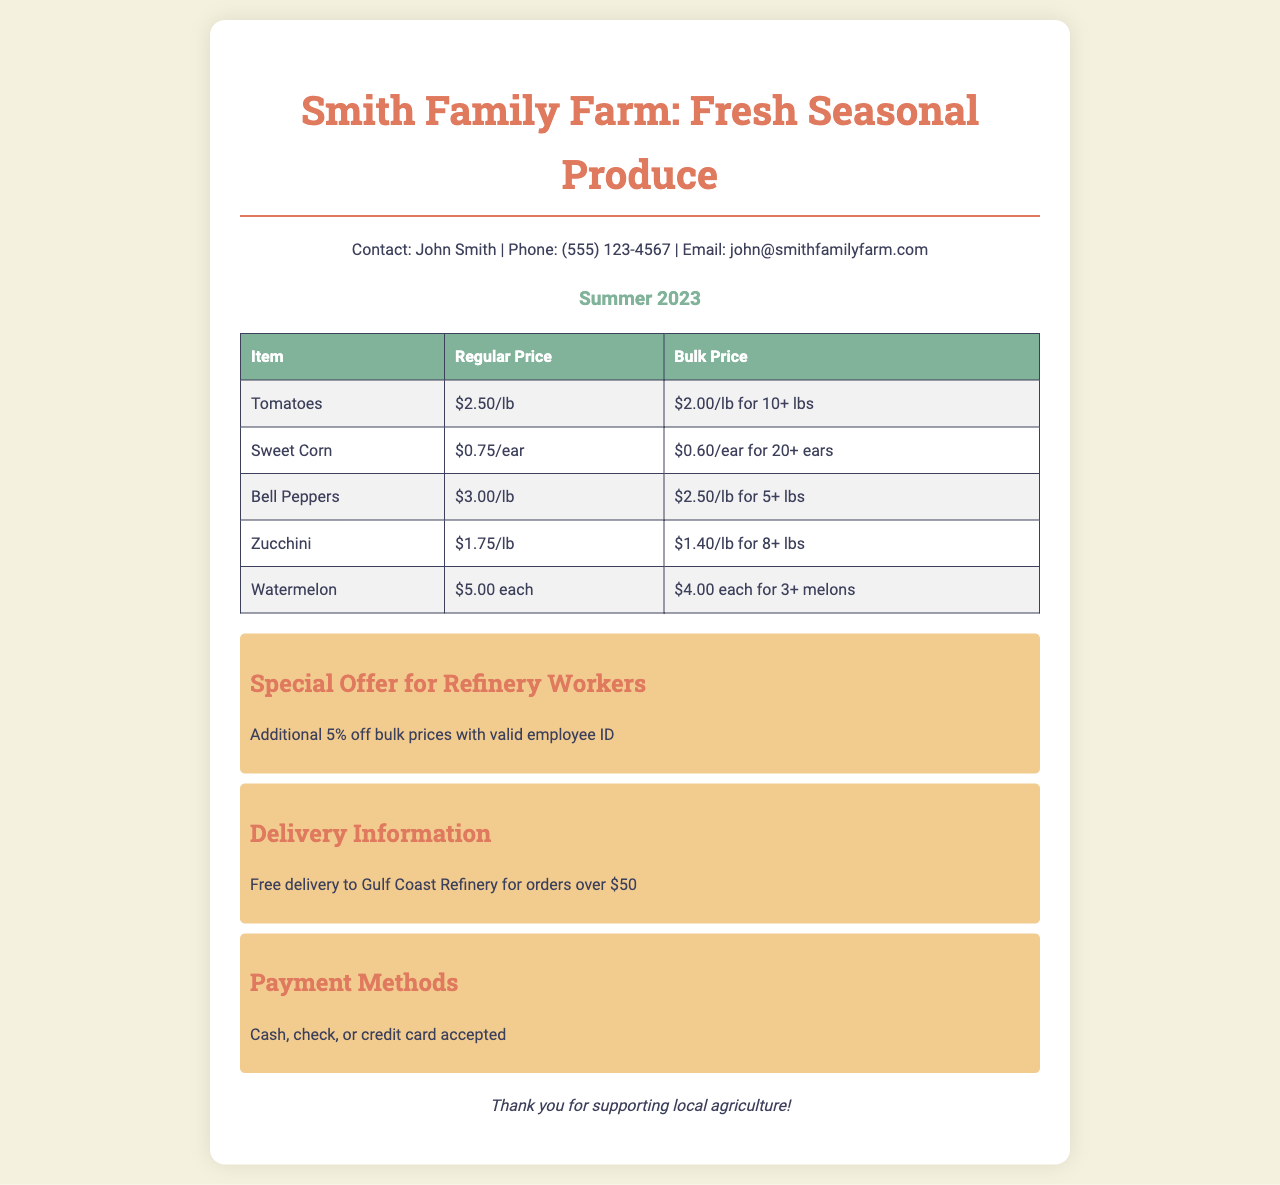What is the contact person's name? The contact person's name is listed at the top of the document.
Answer: John Smith What is the bulk price for tomatoes? The bulk price for tomatoes is specified in the price list table.
Answer: $2.00/lb for 10+ lbs How much do you save on bulk prices with a valid employee ID? The document mentions a specific discount for refinery workers.
Answer: Additional 5% off How much does watermelon cost for three or more? The price for three or more watermelons can be found in the pricing table.
Answer: $4.00 each for 3+ melons What is the minimum order for free delivery? The document states a specific monetary amount for free delivery.
Answer: Orders over $50 How many ears of sweet corn qualify for the bulk price? The condition for the bulk price is mentioned in the table for sweet corn.
Answer: 20+ ears What payment methods are accepted? The document lists the accepted methods for payment.
Answer: Cash, check, or credit card What is the season mentioned in the document? The season for the produce is indicated at the beginning of the document.
Answer: Summer 2023 What is the regular price of bell peppers? The regular price for bell peppers is shown in the price list.
Answer: $3.00/lb 